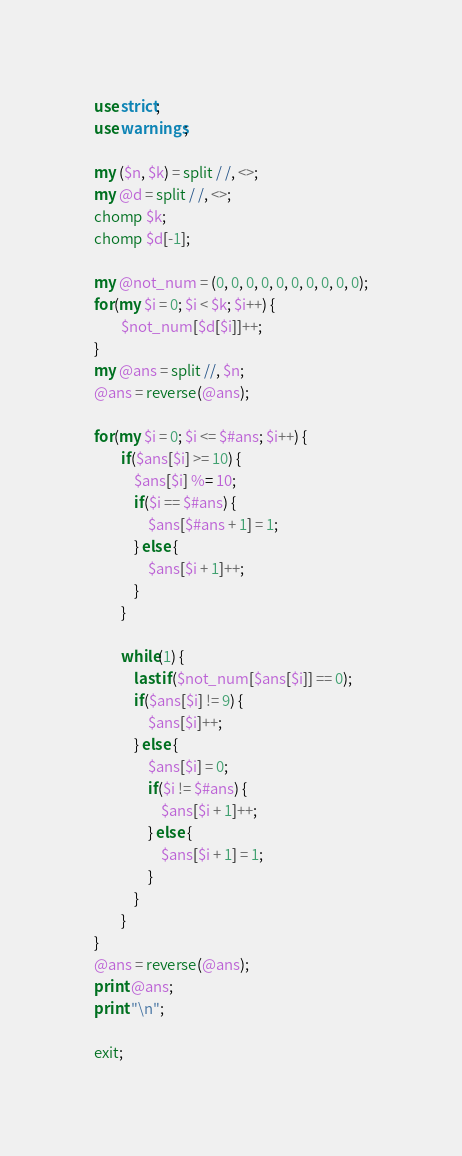Convert code to text. <code><loc_0><loc_0><loc_500><loc_500><_Perl_>use strict;
use warnings;

my ($n, $k) = split / /, <>;
my @d = split / /, <>;
chomp $k;
chomp $d[-1];

my @not_num = (0, 0, 0, 0, 0, 0, 0, 0, 0, 0);
for(my $i = 0; $i < $k; $i++) {
       	$not_num[$d[$i]]++;
}
my @ans = split //, $n;
@ans = reverse(@ans);

for(my $i = 0; $i <= $#ans; $i++) {
       	if($ans[$i] >= 10) {
       		$ans[$i] %= 10;
       		if($i == $#ans) {
       			$ans[$#ans + 1] = 1;
       		} else {
       			$ans[$i + 1]++;
       		}
       	}

       	while(1) {
       		last if($not_num[$ans[$i]] == 0);
       		if($ans[$i] != 9) {
       			$ans[$i]++;
       		} else {
       			$ans[$i] = 0;
       			if($i != $#ans) {
       				$ans[$i + 1]++;
       			} else {
       				$ans[$i + 1] = 1;
       			}
       		}
       	}
}
@ans = reverse(@ans);
print @ans;
print "\n";

exit;</code> 